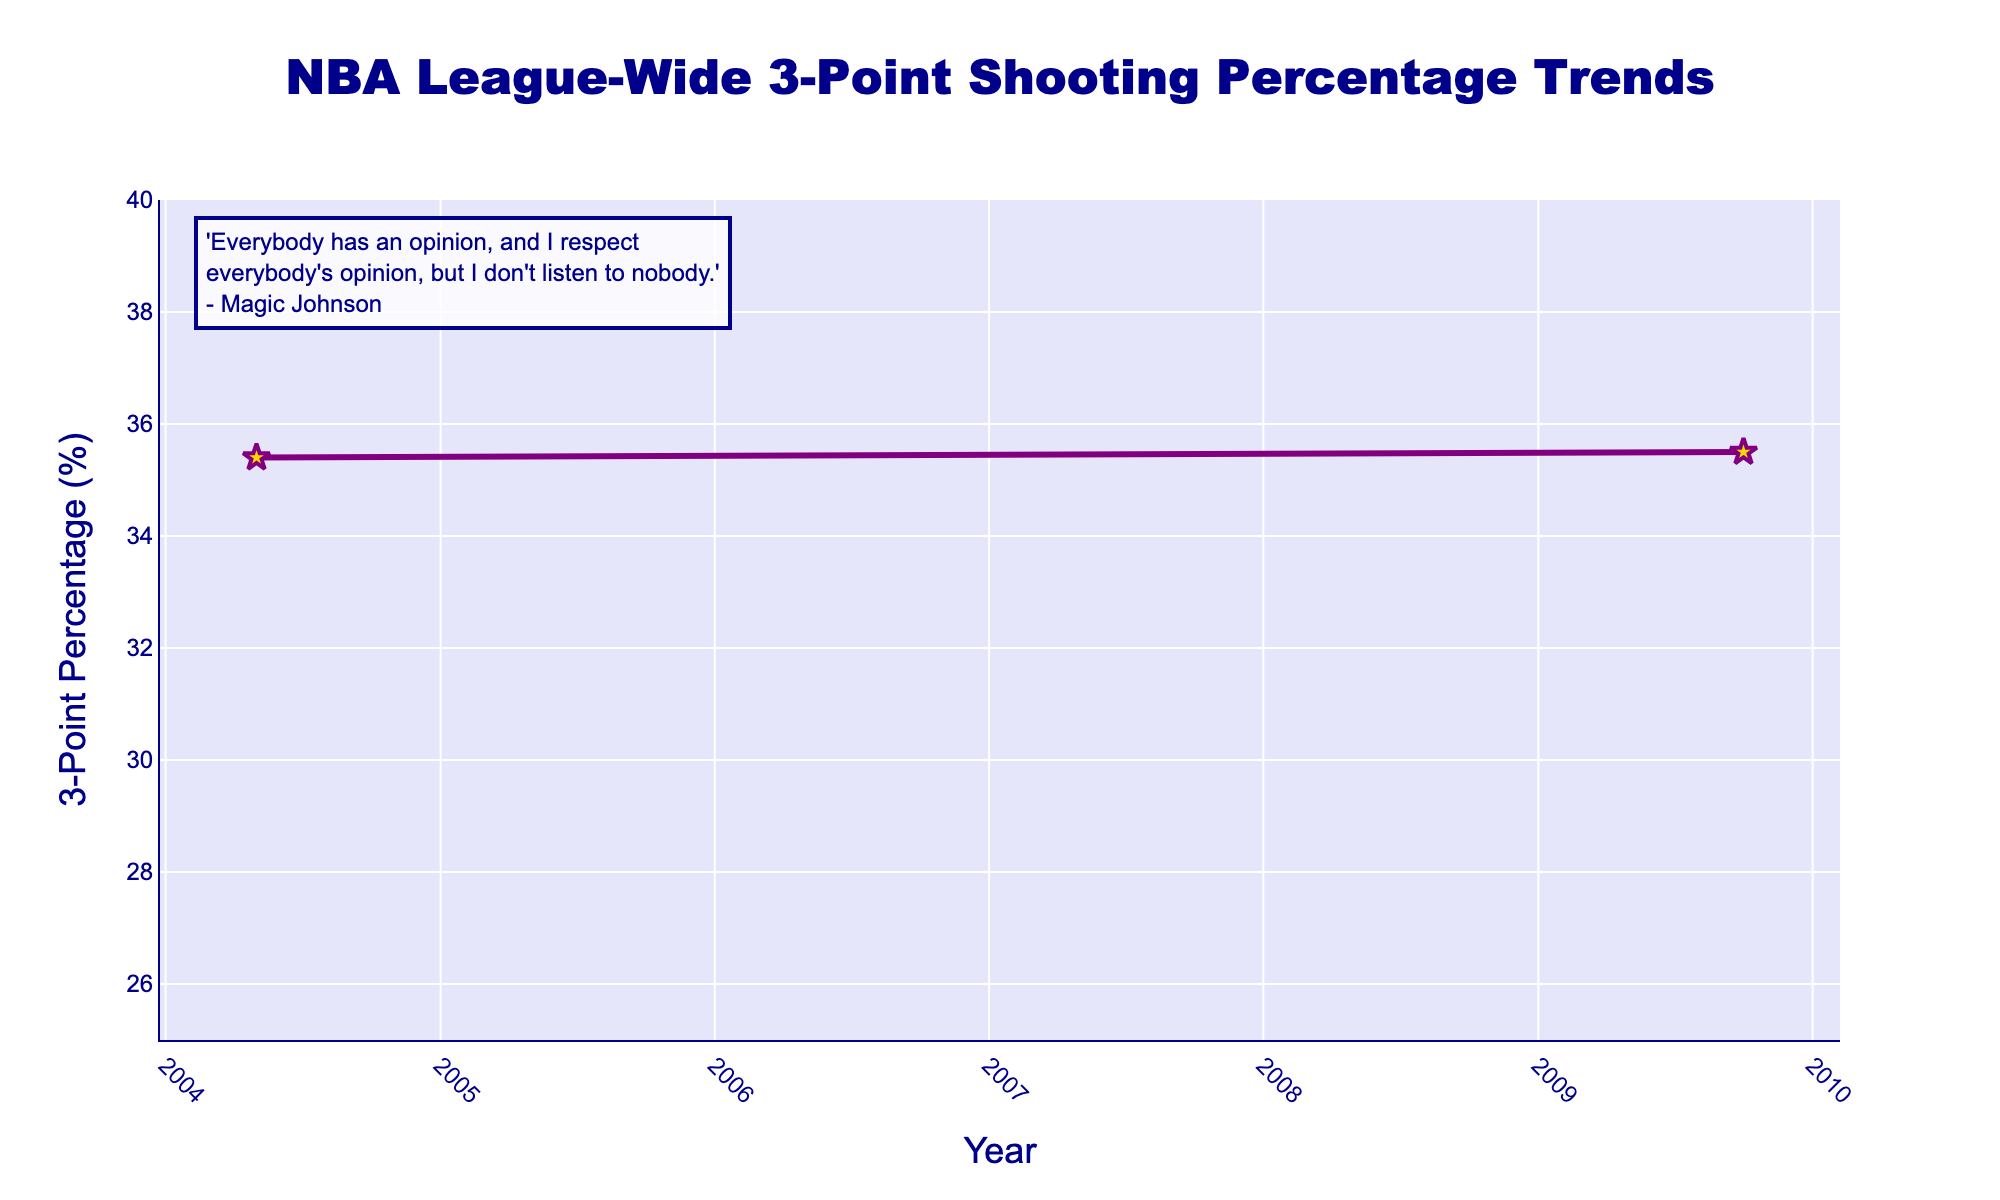What is the highest 3-point shooting percentage recorded in the data? The figure shows values for various years. The highest recorded 3-point shooting percentage is at the far right of the chart for the year 2022-23.
Answer: 36.1% In which year did the league-wide 3-point shooting percentage first exceed 30%? The figure indicates the percentage for different years. The first year the percentage exceeded 30% is around 1989-90.
Answer: 1989-90 By how much did the 3-point shooting percentage change from 1984-85 to 1989-90? The figure shows the 3-point percentage for 1984-85 as 28.2% and for 1989-90 as 33.1%. The change is calculated as 33.1% - 28.2%.
Answer: 4.9% Compare the league-wide 3-point shooting percentage for the years Magic Johnson was active in the league (1979-80 and 1990-91). Was there an increase or decrease? Magic Johnson played from 1979-80 onwards. Comparing 1979-80 (28.0%) and 1989-90 (33.1%), the percentage increased.
Answer: Increase What was the overall trend in 3-point shooting percentage between 1979-80 and 2022-23? Observing the figure from the left to the right, the trend generally shows an increase in the league-wide 3-point shooting percentage over time.
Answer: Increasing trend How did the 3-point shooting percentage change between 2009-10 and 2019-20? The chart indicates the percentages for 2009-10 (35.5%) and 2019-20 (35.8%). The difference is 35.8% - 35.5%.
Answer: 0.3% increase What is the difference in 3-point shooting percentage between its lowest and highest points in the data? The lowest percentage is 28.0% (1979-80) and the highest is 36.1% (2022-23). The difference is 36.1% - 28.0%.
Answer: 8.1% Which year had a 3-point shooting percentage closest to 36%? According to the chart, the year 2022-23 shows a 3-point shooting percentage of 36.1%, which is closest to 36%.
Answer: 2022-23 